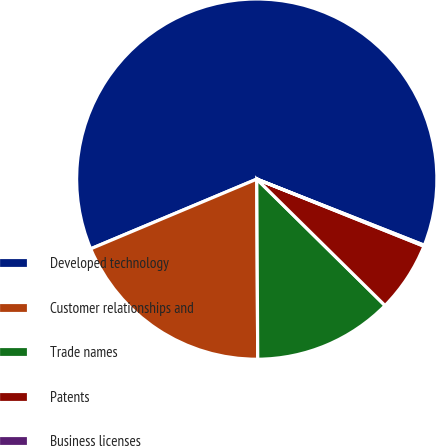<chart> <loc_0><loc_0><loc_500><loc_500><pie_chart><fcel>Developed technology<fcel>Customer relationships and<fcel>Trade names<fcel>Patents<fcel>Business licenses<nl><fcel>62.31%<fcel>18.76%<fcel>12.53%<fcel>6.31%<fcel>0.09%<nl></chart> 